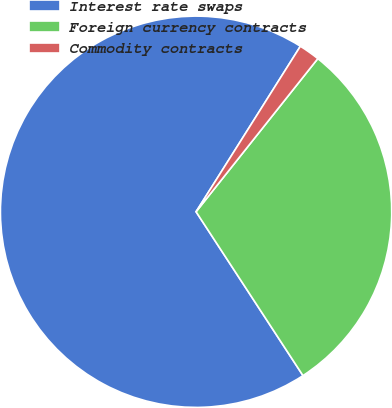<chart> <loc_0><loc_0><loc_500><loc_500><pie_chart><fcel>Interest rate swaps<fcel>Foreign currency contracts<fcel>Commodity contracts<nl><fcel>68.15%<fcel>30.11%<fcel>1.74%<nl></chart> 